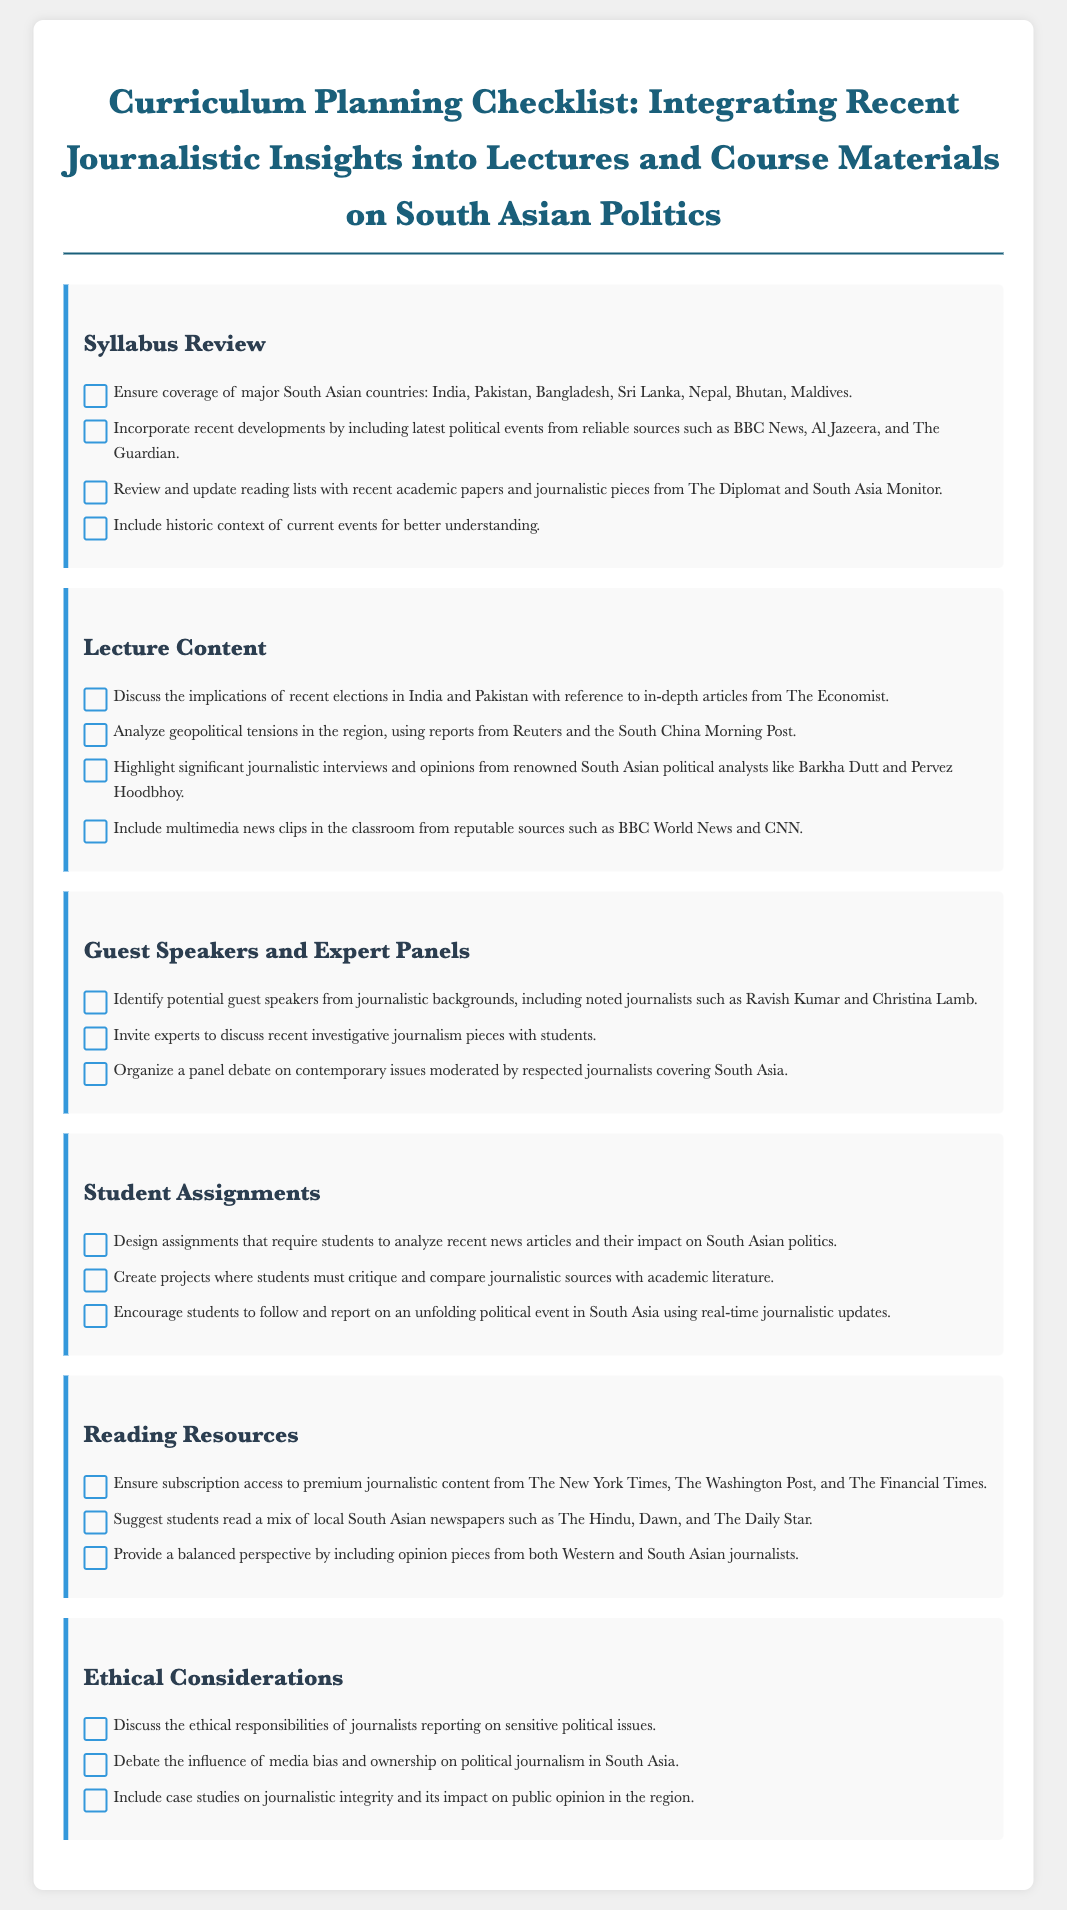What major South Asian countries should be covered in the syllabus? The syllabus should ensure coverage of major South Asian countries, including India, Pakistan, Bangladesh, Sri Lanka, Nepal, Bhutan, and Maldives.
Answer: India, Pakistan, Bangladesh, Sri Lanka, Nepal, Bhutan, Maldives Which sources are recommended for including recent developments? The document suggests incorporating recent developments by including political events from reliable sources such as BBC News, Al Jazeera, and The Guardian.
Answer: BBC News, Al Jazeera, The Guardian What type of analysis should be discussed regarding elections in India and Pakistan? The lecture content should discuss the implications of recent elections in India and Pakistan with reference to in-depth articles from The Economist.
Answer: Implications of recent elections Name two notable guest speakers suggested for the course. Potential guest speakers identified from journalistic backgrounds include noted journalists such as Ravish Kumar and Christina Lamb.
Answer: Ravish Kumar, Christina Lamb What is one of the student assignments recommended? One recommendation for student assignments is to design assignments that require students to analyze recent news articles and their impact on South Asian politics.
Answer: Analyze recent news articles Which newspapers are suggested for reading resources? The document suggests students read a mix of local South Asian newspapers such as The Hindu, Dawn, and The Daily Star.
Answer: The Hindu, Dawn, The Daily Star What ethical topic should be discussed in the curriculum? The curriculum should discuss the ethical responsibilities of journalists reporting on sensitive political issues.
Answer: Ethical responsibilities of journalists 